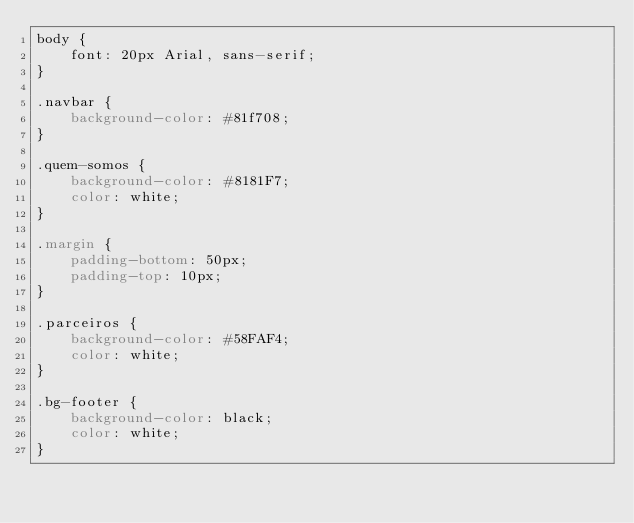<code> <loc_0><loc_0><loc_500><loc_500><_CSS_>body {
    font: 20px Arial, sans-serif; 
}

.navbar {
    background-color: #81f708;
}

.quem-somos {
    background-color: #8181F7;
    color: white;
}

.margin {
    padding-bottom: 50px;
    padding-top: 10px;
}

.parceiros {
    background-color: #58FAF4;
    color: white;
}

.bg-footer {
    background-color: black;
    color: white;
}</code> 